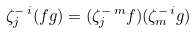Convert formula to latex. <formula><loc_0><loc_0><loc_500><loc_500>\zeta ^ { - \, i } _ { j } ( f g ) = ( \zeta ^ { - \, m } _ { j } f ) ( \zeta ^ { - \, i } _ { m } g )</formula> 